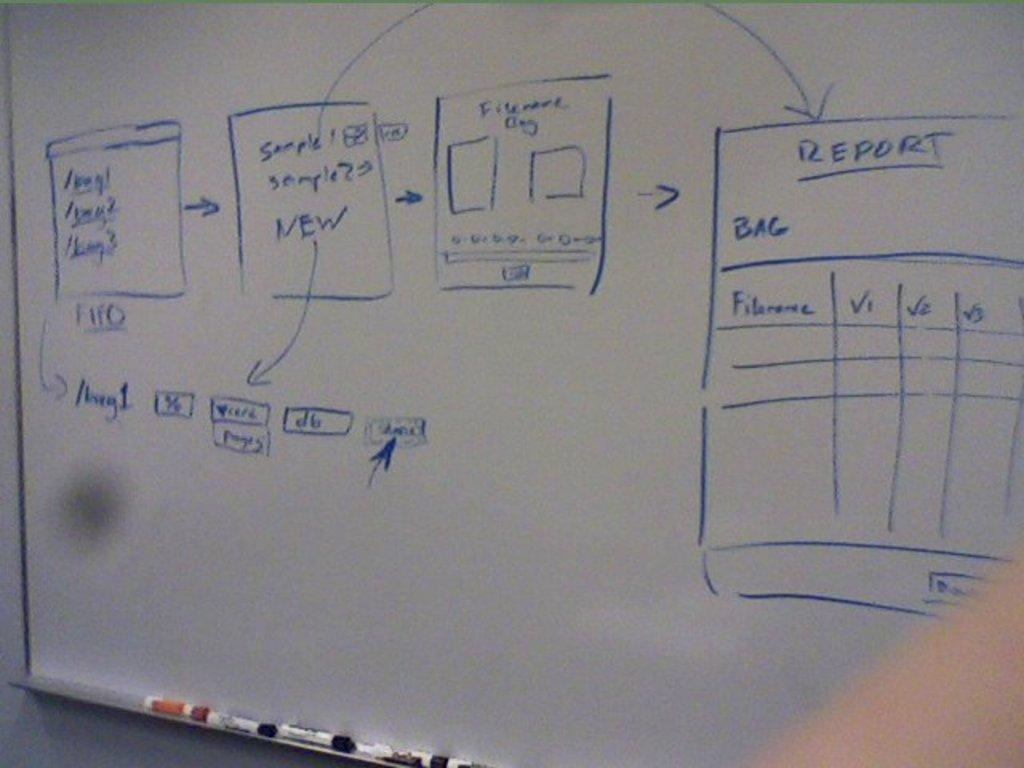<image>
Render a clear and concise summary of the photo. a report that is written on a white board 